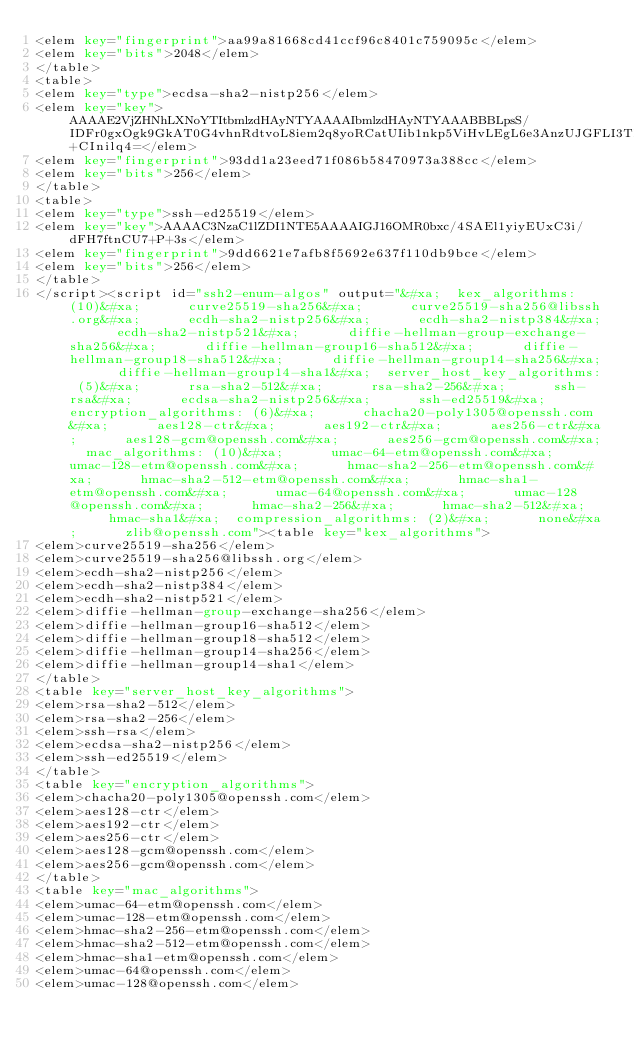<code> <loc_0><loc_0><loc_500><loc_500><_XML_><elem key="fingerprint">aa99a81668cd41ccf96c8401c759095c</elem>
<elem key="bits">2048</elem>
</table>
<table>
<elem key="type">ecdsa-sha2-nistp256</elem>
<elem key="key">AAAAE2VjZHNhLXNoYTItbmlzdHAyNTYAAAAIbmlzdHAyNTYAAABBBLpsS/IDFr0gxOgk9GkAT0G4vhnRdtvoL8iem2q8yoRCatUIib1nkp5ViHvLEgL6e3AnzUJGFLI3TFz+CInilq4=</elem>
<elem key="fingerprint">93dd1a23eed71f086b58470973a388cc</elem>
<elem key="bits">256</elem>
</table>
<table>
<elem key="type">ssh-ed25519</elem>
<elem key="key">AAAAC3NzaC1lZDI1NTE5AAAAIGJ16OMR0bxc/4SAEl1yiyEUxC3i/dFH7ftnCU7+P+3s</elem>
<elem key="fingerprint">9dd6621e7afb8f5692e637f110db9bce</elem>
<elem key="bits">256</elem>
</table>
</script><script id="ssh2-enum-algos" output="&#xa;  kex_algorithms: (10)&#xa;      curve25519-sha256&#xa;      curve25519-sha256@libssh.org&#xa;      ecdh-sha2-nistp256&#xa;      ecdh-sha2-nistp384&#xa;      ecdh-sha2-nistp521&#xa;      diffie-hellman-group-exchange-sha256&#xa;      diffie-hellman-group16-sha512&#xa;      diffie-hellman-group18-sha512&#xa;      diffie-hellman-group14-sha256&#xa;      diffie-hellman-group14-sha1&#xa;  server_host_key_algorithms: (5)&#xa;      rsa-sha2-512&#xa;      rsa-sha2-256&#xa;      ssh-rsa&#xa;      ecdsa-sha2-nistp256&#xa;      ssh-ed25519&#xa;  encryption_algorithms: (6)&#xa;      chacha20-poly1305@openssh.com&#xa;      aes128-ctr&#xa;      aes192-ctr&#xa;      aes256-ctr&#xa;      aes128-gcm@openssh.com&#xa;      aes256-gcm@openssh.com&#xa;  mac_algorithms: (10)&#xa;      umac-64-etm@openssh.com&#xa;      umac-128-etm@openssh.com&#xa;      hmac-sha2-256-etm@openssh.com&#xa;      hmac-sha2-512-etm@openssh.com&#xa;      hmac-sha1-etm@openssh.com&#xa;      umac-64@openssh.com&#xa;      umac-128@openssh.com&#xa;      hmac-sha2-256&#xa;      hmac-sha2-512&#xa;      hmac-sha1&#xa;  compression_algorithms: (2)&#xa;      none&#xa;      zlib@openssh.com"><table key="kex_algorithms">
<elem>curve25519-sha256</elem>
<elem>curve25519-sha256@libssh.org</elem>
<elem>ecdh-sha2-nistp256</elem>
<elem>ecdh-sha2-nistp384</elem>
<elem>ecdh-sha2-nistp521</elem>
<elem>diffie-hellman-group-exchange-sha256</elem>
<elem>diffie-hellman-group16-sha512</elem>
<elem>diffie-hellman-group18-sha512</elem>
<elem>diffie-hellman-group14-sha256</elem>
<elem>diffie-hellman-group14-sha1</elem>
</table>
<table key="server_host_key_algorithms">
<elem>rsa-sha2-512</elem>
<elem>rsa-sha2-256</elem>
<elem>ssh-rsa</elem>
<elem>ecdsa-sha2-nistp256</elem>
<elem>ssh-ed25519</elem>
</table>
<table key="encryption_algorithms">
<elem>chacha20-poly1305@openssh.com</elem>
<elem>aes128-ctr</elem>
<elem>aes192-ctr</elem>
<elem>aes256-ctr</elem>
<elem>aes128-gcm@openssh.com</elem>
<elem>aes256-gcm@openssh.com</elem>
</table>
<table key="mac_algorithms">
<elem>umac-64-etm@openssh.com</elem>
<elem>umac-128-etm@openssh.com</elem>
<elem>hmac-sha2-256-etm@openssh.com</elem>
<elem>hmac-sha2-512-etm@openssh.com</elem>
<elem>hmac-sha1-etm@openssh.com</elem>
<elem>umac-64@openssh.com</elem>
<elem>umac-128@openssh.com</elem></code> 